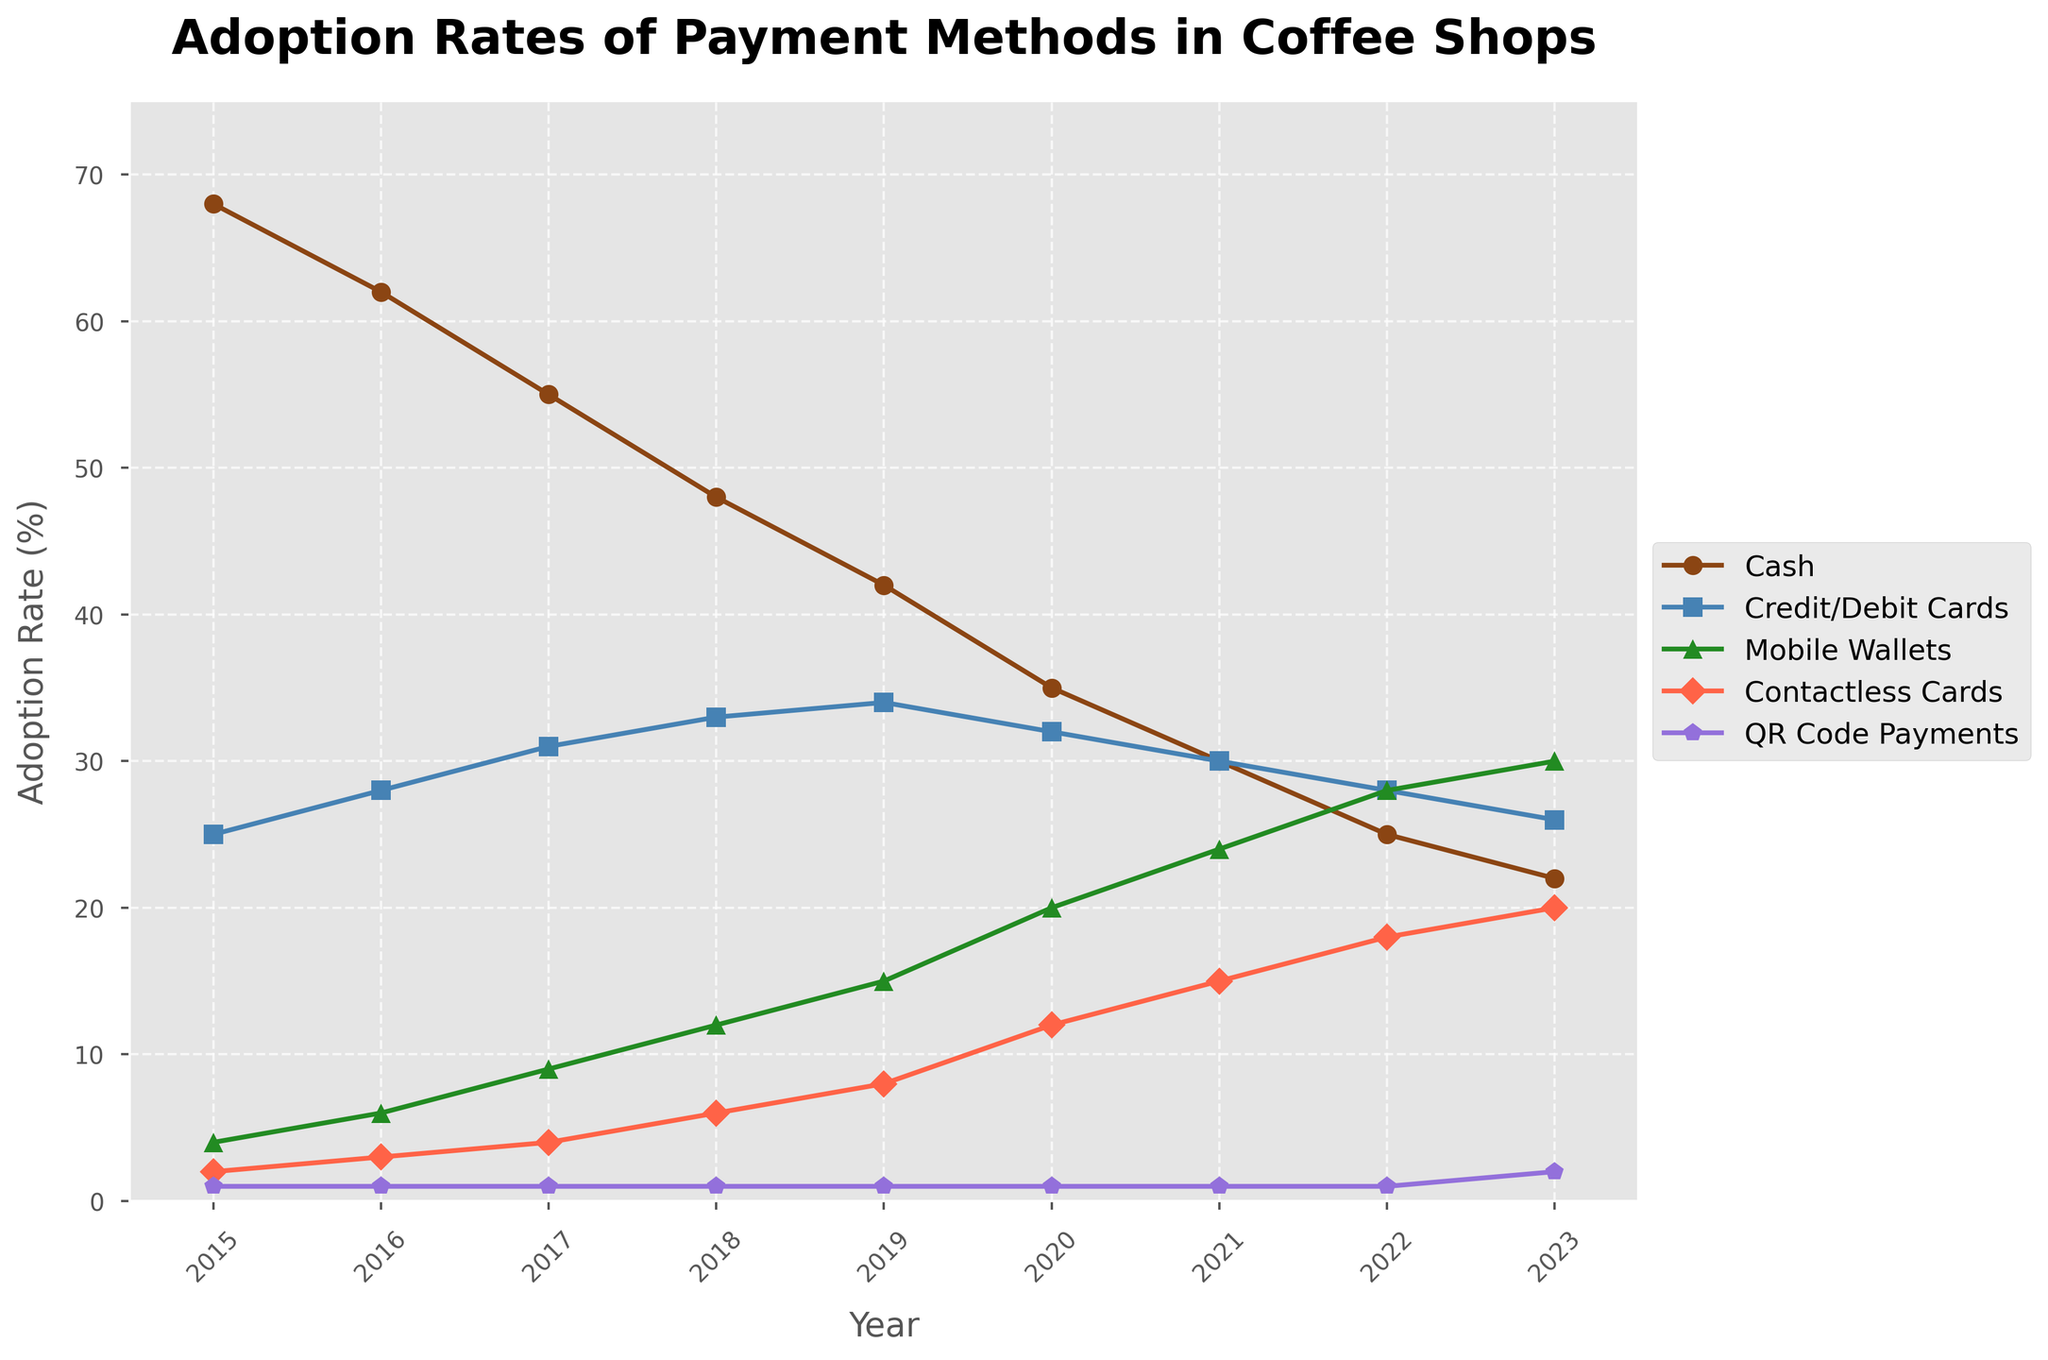What is the adoption rate of Mobile Wallets in 2020? Look at the data point for Mobile Wallets in the year 2020 on the line chart.
Answer: 20% How has the adoption rate of Cash changed from 2015 to 2023? Compare the adoption rates of Cash in 2015 and 2023: 68% in 2015 and 22% in 2023. Subtract 22 from 68.
Answer: Decreased by 46% Which payment method had the highest adoption rate in 2015? Look at the highest data point among all payment methods in 2015.
Answer: Cash By how much did the adoption rate of Credit/Debit Cards increase from 2015 to 2023? Compare the adoption rates of Credit/Debit Cards in 2015 (25%) and 2023 (26%). Subtract 25 from 26.
Answer: Increased by 1% Which year saw the biggest increase in adoption rate for Contactless Cards? Compare the year-over-year increase for Contactless Cards and identify the year with the largest increase.
Answer: 2020 What was the trend for QR Code Payments over the years 2015 to 2023? Observe the line for QR Code Payments across the years.
Answer: Mostly stable, slight increase in 2023 In what year did the adoption of Mobile Wallets surpass that of Credit/Debit Cards? Compare the lines for Mobile Wallets and Credit/Debit Cards and find the year when Mobile Wallets' rate first exceeds that of Credit/Debit Cards.
Answer: 2022 Which payment method showed consistent growth every year? Identify the payment method whose line consistently increases each year from 2015 to 2023.
Answer: Mobile Wallets and Contactless Cards What is the average adoption rate of Cash over the years 2015 to 2023? Sum the adoption rates of Cash from 2015 to 2023 (68 + 62 + 55 + 48 + 42 + 35 + 30 + 25 + 22 = 387). Divide by 9 (the number of years) to get the average.
Answer: 43% How did the adoption rate of Contactless Cards change from 2015 to 2018? Compare the adoption rates of Contactless Cards in 2015 (2%) and 2018 (6%), and calculate the difference.
Answer: Increased by 4% 